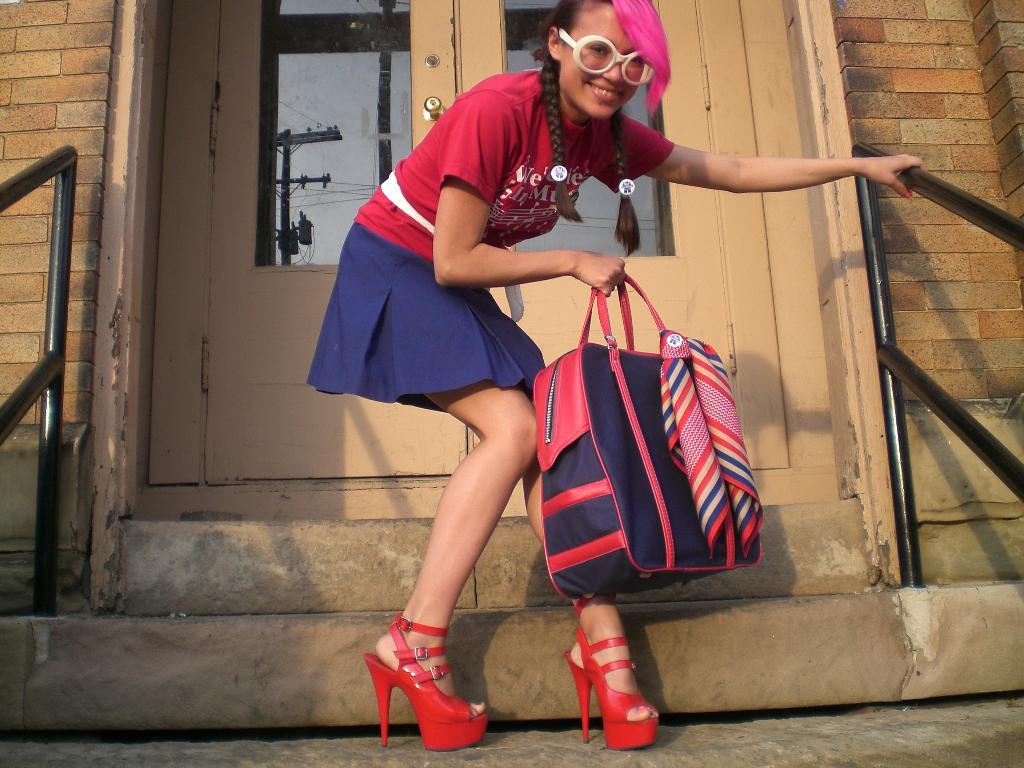Who is present in the image? There is a woman in the image. What is the woman holding in the image? The woman is holding a bag. What is the woman's facial expression in the image? The woman is smiling. What can be seen in the background of the image? There is a building in the background of the image. What feature of the building is mentioned in the facts? The building has doors. What type of music can be heard playing in the background of the image? There is no music present in the image, as it is a still photograph. Is there an airport visible in the image? No, there is no airport mentioned or visible in the image. 